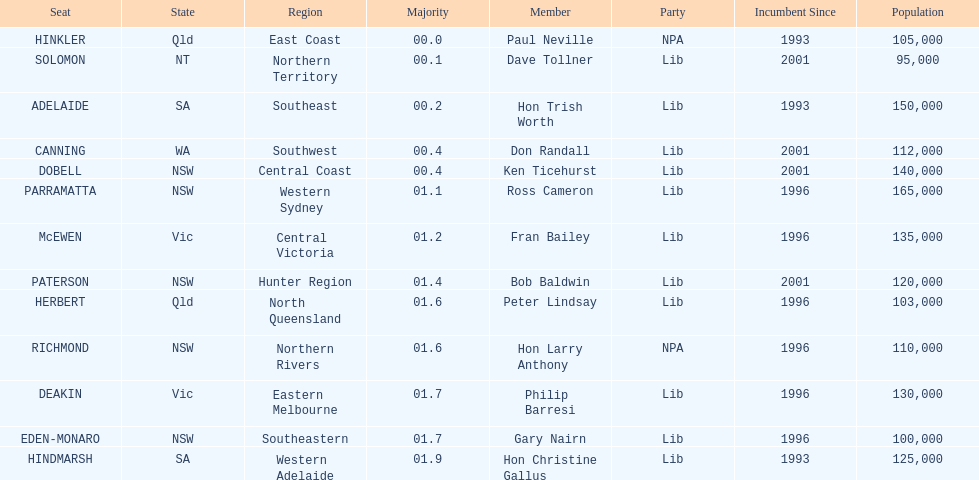What is the difference in majority between hindmarsh and hinkler? 01.9. 